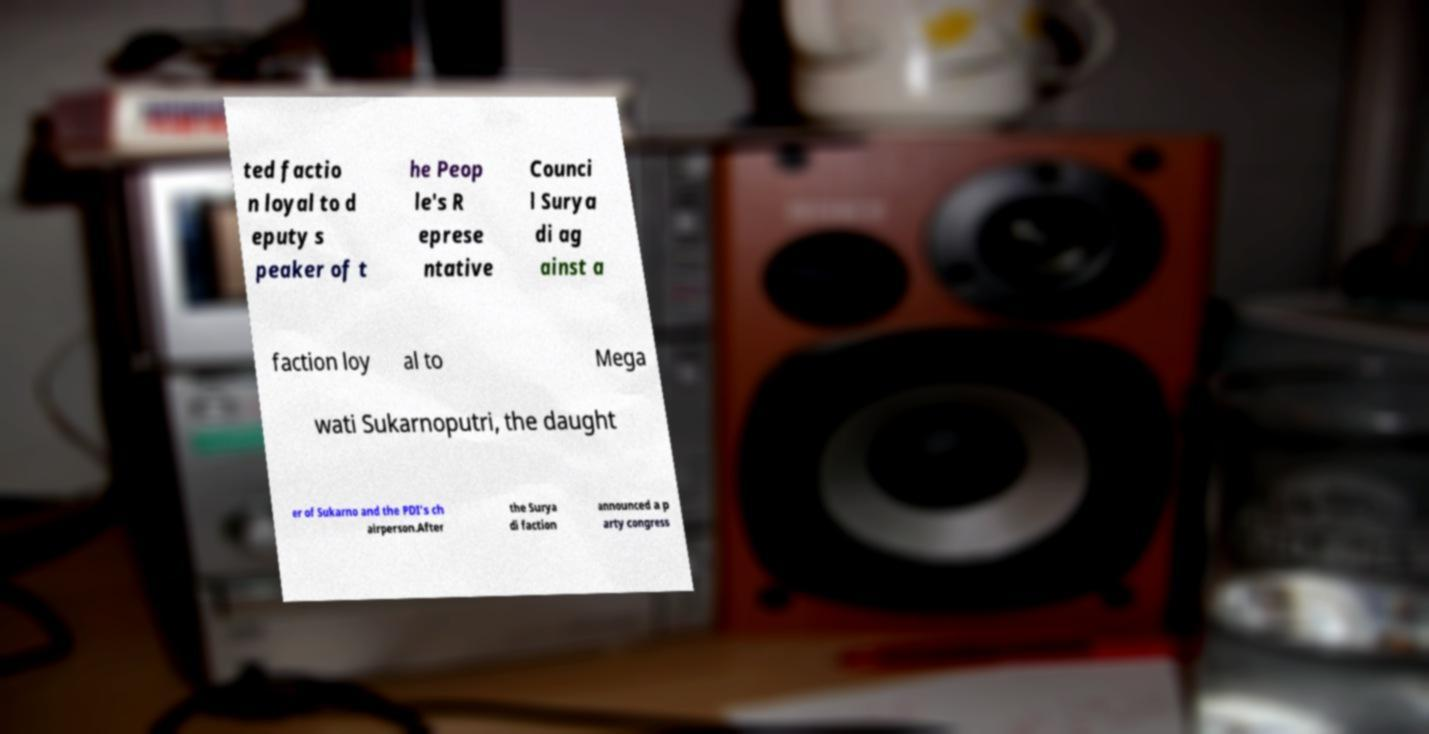Can you read and provide the text displayed in the image?This photo seems to have some interesting text. Can you extract and type it out for me? ted factio n loyal to d eputy s peaker of t he Peop le's R eprese ntative Counci l Surya di ag ainst a faction loy al to Mega wati Sukarnoputri, the daught er of Sukarno and the PDI's ch airperson.After the Surya di faction announced a p arty congress 